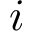<formula> <loc_0><loc_0><loc_500><loc_500>i</formula> 